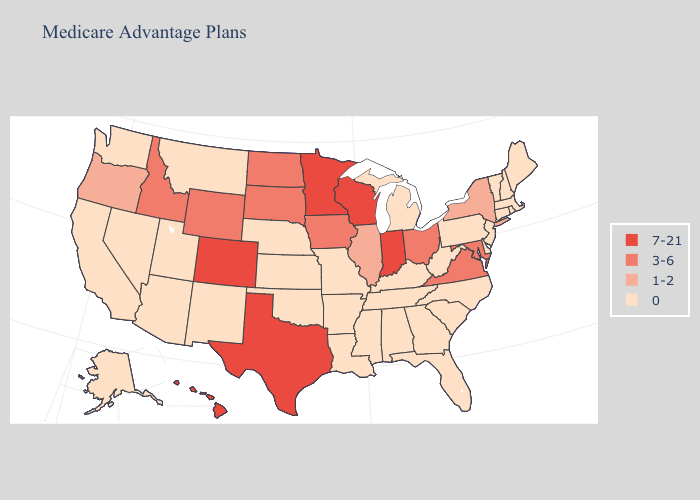Does Kentucky have the same value as Iowa?
Answer briefly. No. What is the highest value in the USA?
Write a very short answer. 7-21. What is the highest value in the Northeast ?
Short answer required. 1-2. Does Utah have a lower value than Kentucky?
Answer briefly. No. What is the highest value in states that border Massachusetts?
Be succinct. 1-2. Does the map have missing data?
Quick response, please. No. What is the value of Nebraska?
Quick response, please. 0. Which states hav the highest value in the South?
Concise answer only. Texas. What is the highest value in states that border North Carolina?
Quick response, please. 3-6. What is the value of Illinois?
Concise answer only. 1-2. Name the states that have a value in the range 1-2?
Answer briefly. Illinois, New York, Oregon. Name the states that have a value in the range 0?
Write a very short answer. Alaska, Alabama, Arkansas, Arizona, California, Connecticut, Delaware, Florida, Georgia, Kansas, Kentucky, Louisiana, Massachusetts, Maine, Michigan, Missouri, Mississippi, Montana, North Carolina, Nebraska, New Hampshire, New Jersey, New Mexico, Nevada, Oklahoma, Pennsylvania, Rhode Island, South Carolina, Tennessee, Utah, Vermont, Washington, West Virginia. Name the states that have a value in the range 3-6?
Keep it brief. Iowa, Idaho, Maryland, North Dakota, Ohio, South Dakota, Virginia, Wyoming. How many symbols are there in the legend?
Quick response, please. 4. What is the lowest value in the West?
Write a very short answer. 0. 